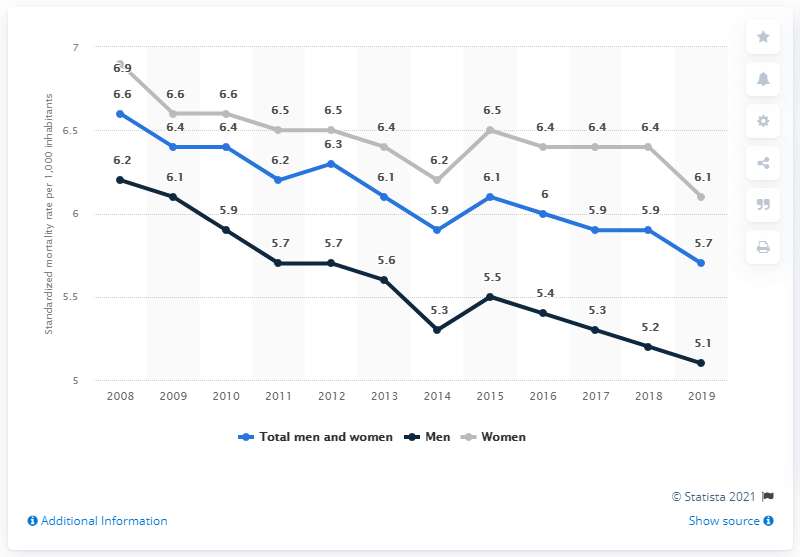Draw attention to some important aspects in this diagram. The standardized male mortality rate in the Netherlands in 2016 was 5.4. In 2019, the standardized mortality rate per 1,000 inhabitants in the Netherlands was 5.7. The standardized women mortality rate has exceeded 6.2 in at least four years. 